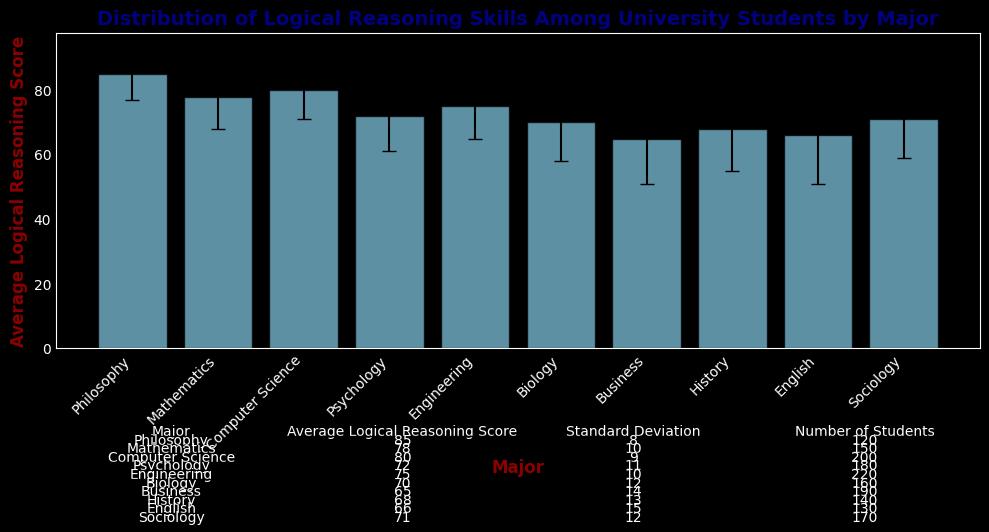What's the major with the highest average logical reasoning score? From the figure, the heights of the bars represent the average logical reasoning scores. The Philosophy bar is the tallest.
Answer: Philosophy What's the difference in the average logical reasoning scores between Mathematics and Sociology majors? The average score for Mathematics is 78, and for Sociology, it is 71. Subtract the Sociology score from the Mathematics score: 78 - 71.
Answer: 7 Which major has the highest standard deviation in logical reasoning scores? The table below the chart lists the standard deviations for each major. The English major has the highest standard deviation of 15.
Answer: English Which two majors have the closest average logical reasoning scores? Look for bars with similar heights. The Mathematics major (78) and the Computer Science major (80) scores are the closest, differing by 2 points.
Answer: Mathematics and Computer Science How does the number of students in Engineering compare to the number of students in Philosophy? The table shows 220 students in Engineering and 120 students in Philosophy, so Engineering has more students.
Answer: Engineering has more students What is the range of the average logical reasoning scores across all majors? The highest average score is for Philosophy (85) and the lowest is for Business (65). The range is 85 - 65.
Answer: 20 Which two majors have the largest difference in their standard deviations? The table shows the standard deviations. English has the highest (15) and Philosophy has the lowest (8). The difference is 15 - 8.
Answer: 7 